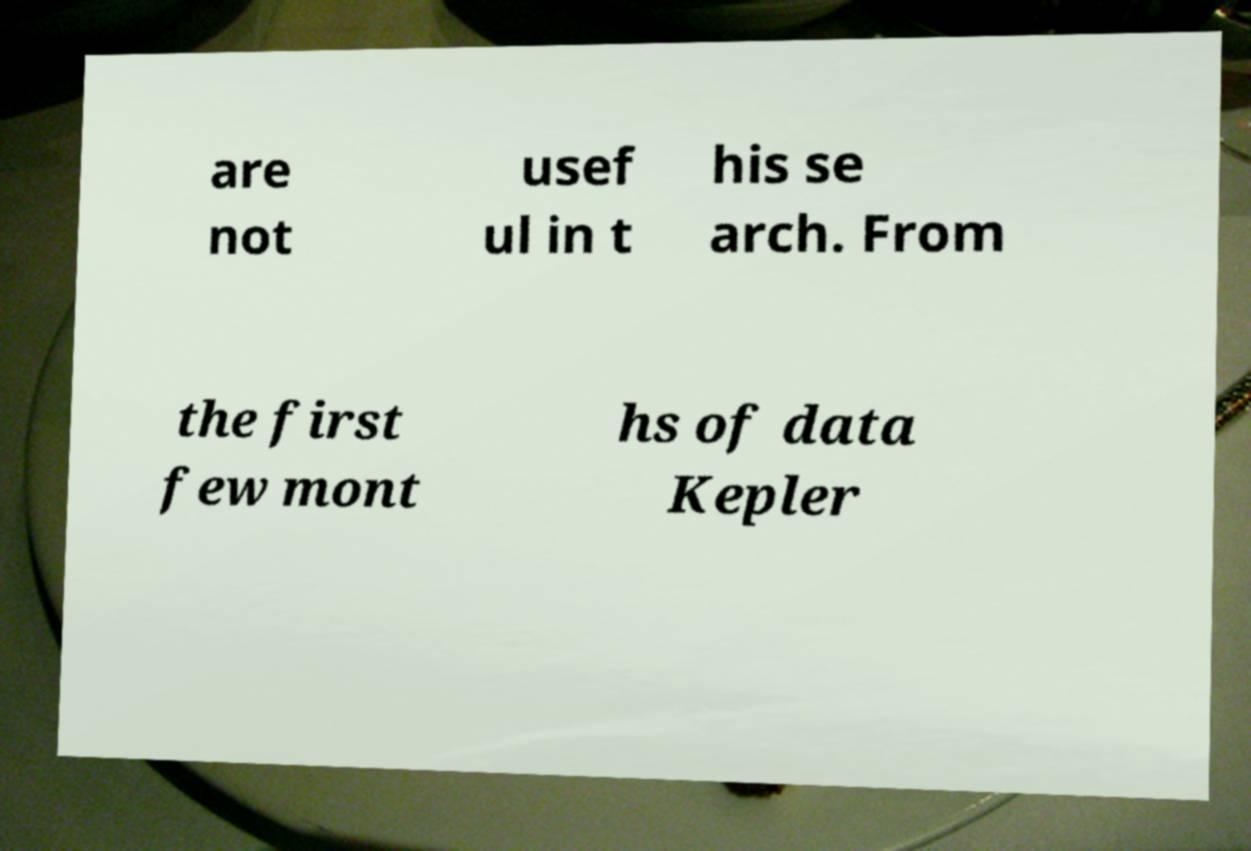Please identify and transcribe the text found in this image. are not usef ul in t his se arch. From the first few mont hs of data Kepler 